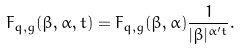<formula> <loc_0><loc_0><loc_500><loc_500>F _ { q , g } ( \beta , \alpha , t ) = F _ { q , g } ( \beta , \alpha ) \frac { 1 } { | \beta | ^ { \alpha ^ { \prime } t } } .</formula> 